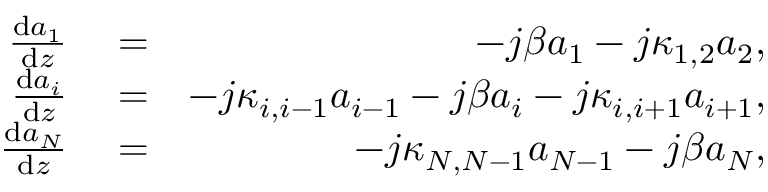<formula> <loc_0><loc_0><loc_500><loc_500>\begin{array} { r l r } { \frac { d a _ { 1 } } { d z } } & = } & { - j \beta a _ { 1 } - j \kappa _ { 1 , 2 } a _ { 2 } , } \\ { \frac { d a _ { i } } { d z } } & = } & { - j \kappa _ { i , i - 1 } a _ { i - 1 } - j \beta a _ { i } - j \kappa _ { i , i + 1 } a _ { i + 1 } , } \\ { \frac { d a _ { N } } { d z } } & = } & { - j \kappa _ { N , N - 1 } a _ { N - 1 } - j \beta a _ { N } , } \end{array}</formula> 